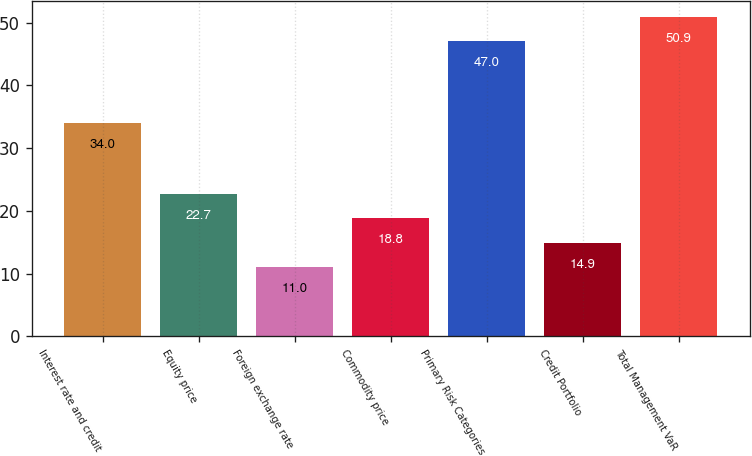<chart> <loc_0><loc_0><loc_500><loc_500><bar_chart><fcel>Interest rate and credit<fcel>Equity price<fcel>Foreign exchange rate<fcel>Commodity price<fcel>Primary Risk Categories<fcel>Credit Portfolio<fcel>Total Management VaR<nl><fcel>34<fcel>22.7<fcel>11<fcel>18.8<fcel>47<fcel>14.9<fcel>50.9<nl></chart> 